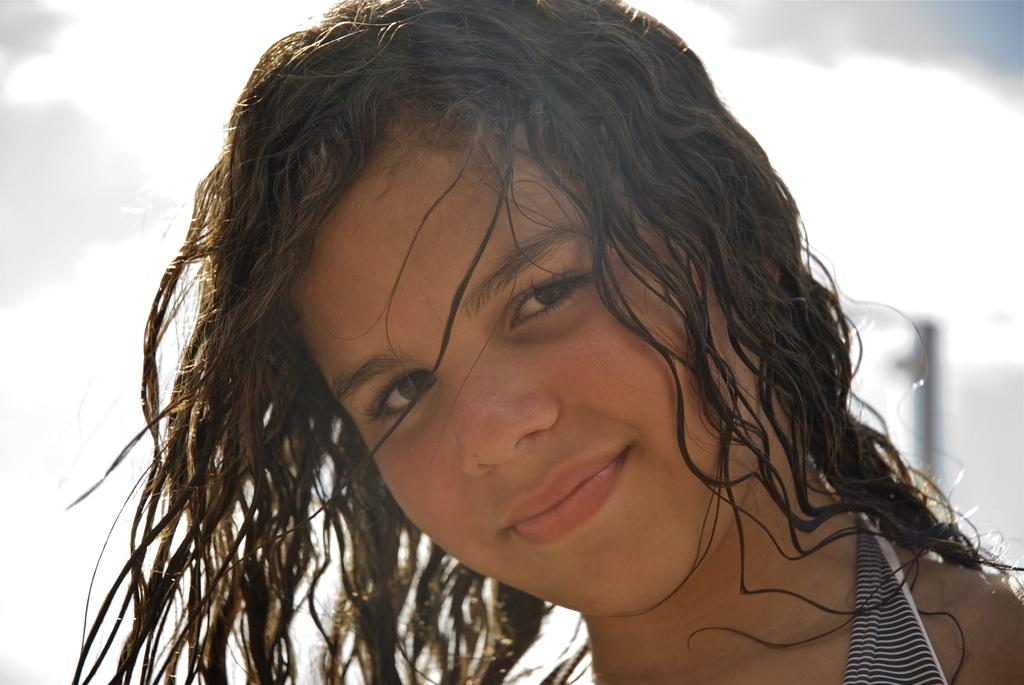Who is the main subject in the image? There is a girl in the image. What is the girl doing in the image? The girl is smiling in the image. Can you describe the background of the image? The background of the image is blurred. What type of string is the girl holding in the image? There is no string present in the image. What kind of vessel is the girl using to drink in the image? There is no vessel or drinking activity depicted in the image. 